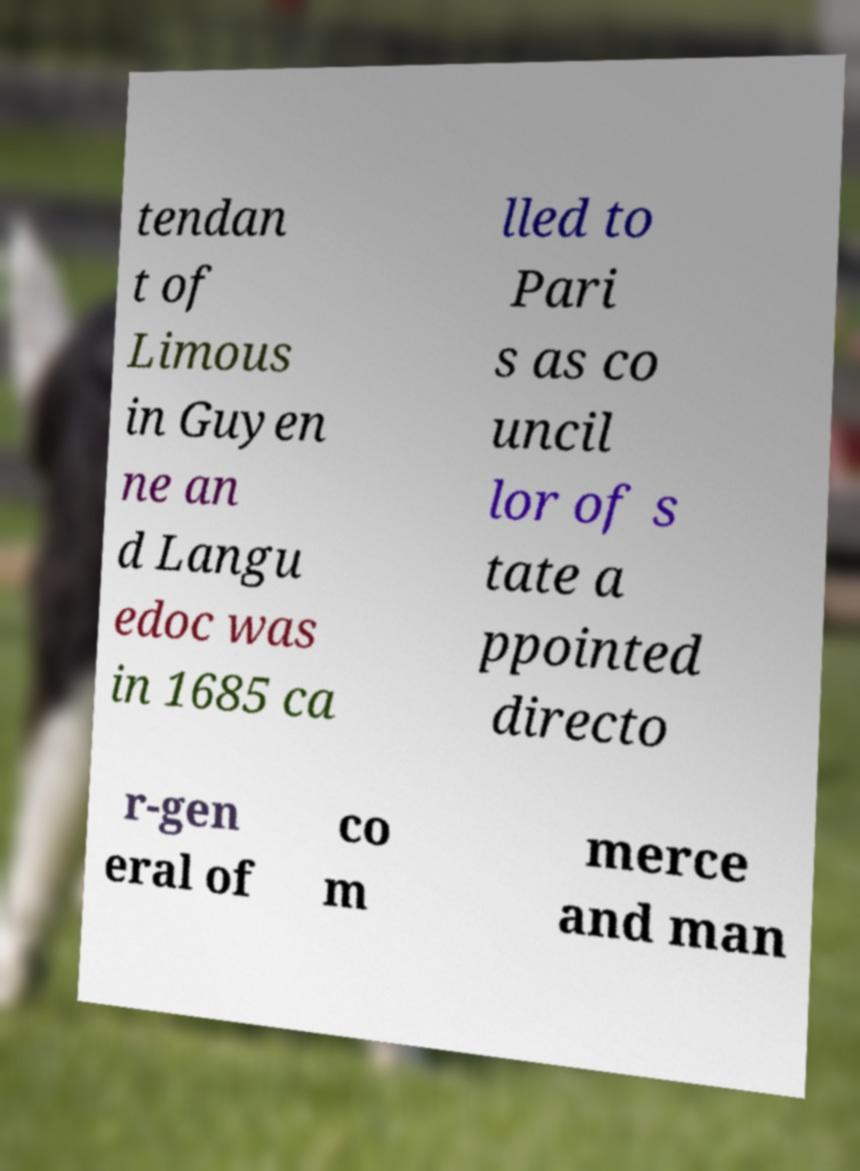Could you extract and type out the text from this image? tendan t of Limous in Guyen ne an d Langu edoc was in 1685 ca lled to Pari s as co uncil lor of s tate a ppointed directo r-gen eral of co m merce and man 